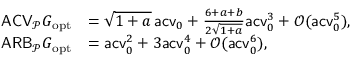<formula> <loc_0><loc_0><loc_500><loc_500>\begin{array} { r l } { A C V _ { \mathcal { P } } G _ { o p t } } & { = \sqrt { 1 + a } \, a c v _ { 0 } + \frac { 6 + a + b } { 2 \sqrt { 1 + a } } a c v _ { 0 } ^ { 3 } + \mathcal { O } ( a c v _ { 0 } ^ { 5 } ) , } \\ { A R B _ { \mathcal { P } } G _ { o p t } } & { = a c v _ { 0 } ^ { 2 } + 3 a c v _ { 0 } ^ { 4 } + \mathcal { O } ( a c v _ { 0 } ^ { 6 } ) , } \end{array}</formula> 